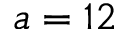Convert formula to latex. <formula><loc_0><loc_0><loc_500><loc_500>a = 1 2</formula> 